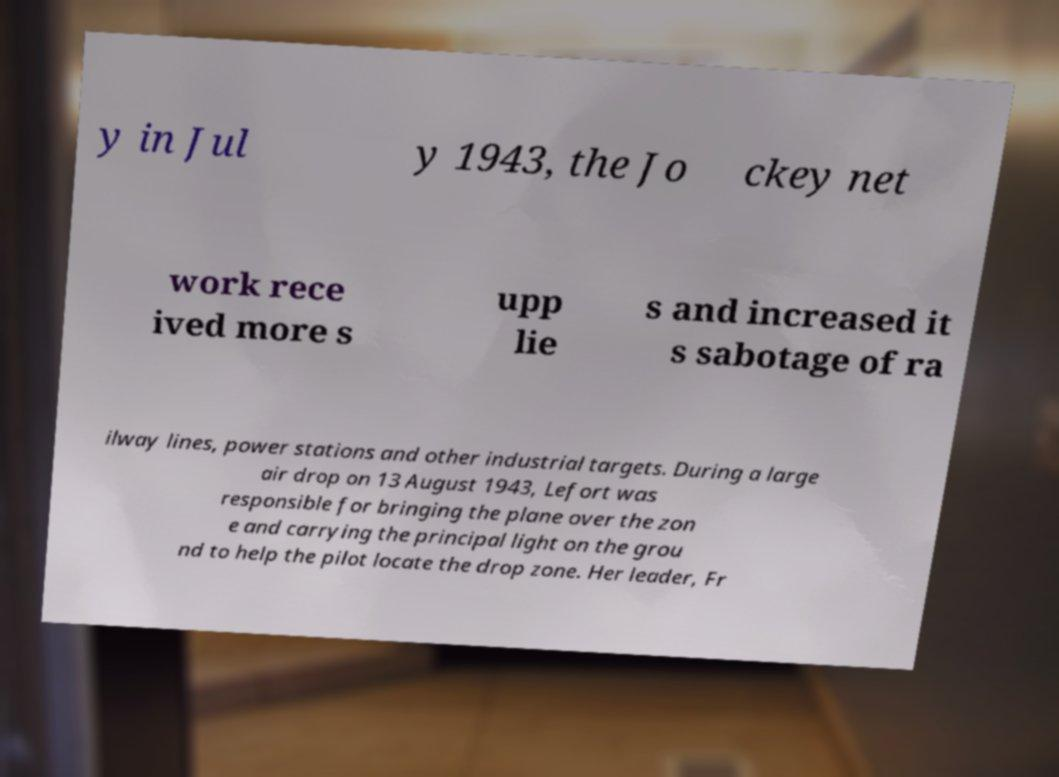Can you read and provide the text displayed in the image?This photo seems to have some interesting text. Can you extract and type it out for me? y in Jul y 1943, the Jo ckey net work rece ived more s upp lie s and increased it s sabotage of ra ilway lines, power stations and other industrial targets. During a large air drop on 13 August 1943, Lefort was responsible for bringing the plane over the zon e and carrying the principal light on the grou nd to help the pilot locate the drop zone. Her leader, Fr 